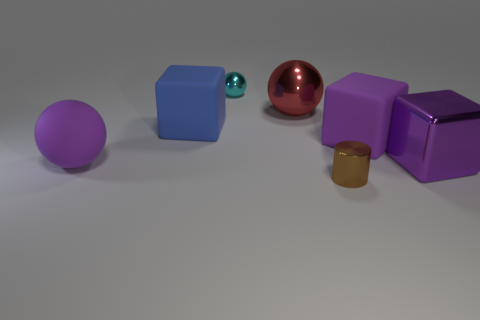Are there any rubber spheres of the same color as the small shiny sphere?
Your answer should be compact. No. Does the cyan ball have the same size as the brown cylinder?
Your answer should be compact. Yes. Do the tiny ball and the large metallic sphere have the same color?
Ensure brevity in your answer.  No. What is the material of the big block to the right of the large matte object that is on the right side of the tiny brown object?
Your response must be concise. Metal. What is the material of the small thing that is the same shape as the big red metallic object?
Keep it short and to the point. Metal. There is a rubber object to the right of the red object; is its size the same as the small metallic cylinder?
Provide a short and direct response. No. What number of rubber things are large gray balls or small cyan spheres?
Provide a succinct answer. 0. The object that is both in front of the purple matte ball and behind the small brown metallic thing is made of what material?
Your answer should be very brief. Metal. Is the big blue cube made of the same material as the big red sphere?
Make the answer very short. No. There is a metallic thing that is in front of the blue matte thing and behind the tiny metallic cylinder; what size is it?
Give a very brief answer. Large. 